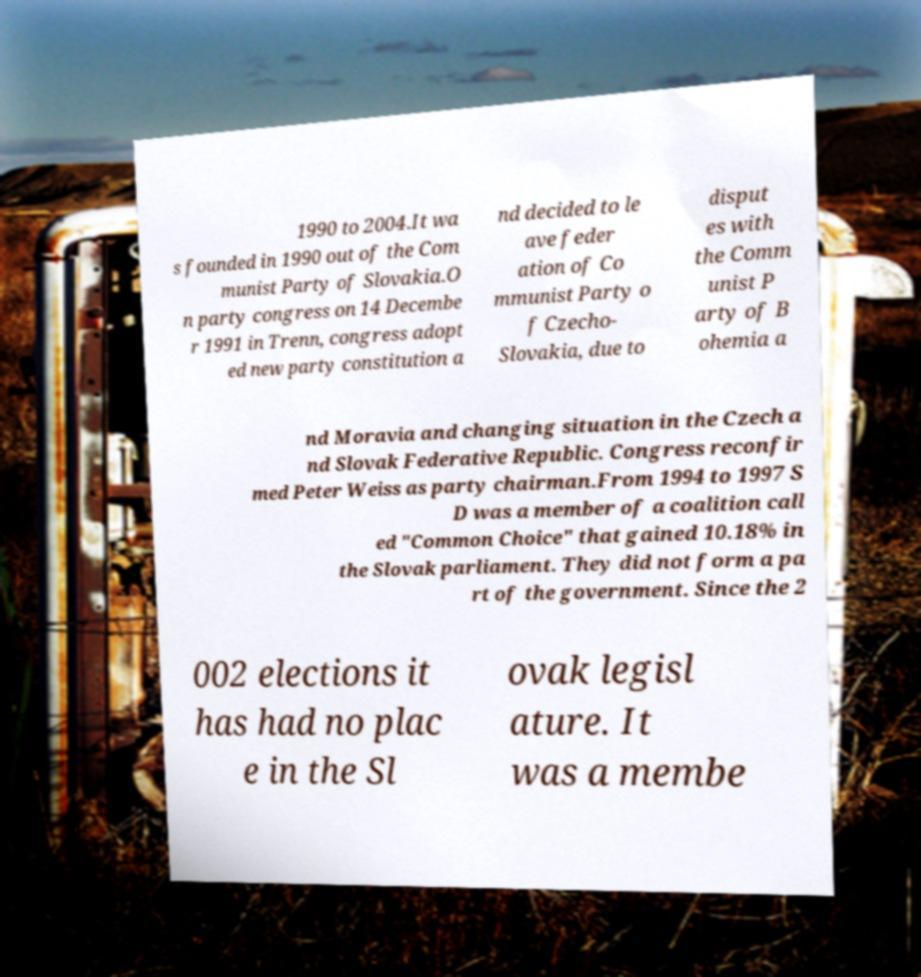What messages or text are displayed in this image? I need them in a readable, typed format. 1990 to 2004.It wa s founded in 1990 out of the Com munist Party of Slovakia.O n party congress on 14 Decembe r 1991 in Trenn, congress adopt ed new party constitution a nd decided to le ave feder ation of Co mmunist Party o f Czecho- Slovakia, due to disput es with the Comm unist P arty of B ohemia a nd Moravia and changing situation in the Czech a nd Slovak Federative Republic. Congress reconfir med Peter Weiss as party chairman.From 1994 to 1997 S D was a member of a coalition call ed "Common Choice" that gained 10.18% in the Slovak parliament. They did not form a pa rt of the government. Since the 2 002 elections it has had no plac e in the Sl ovak legisl ature. It was a membe 